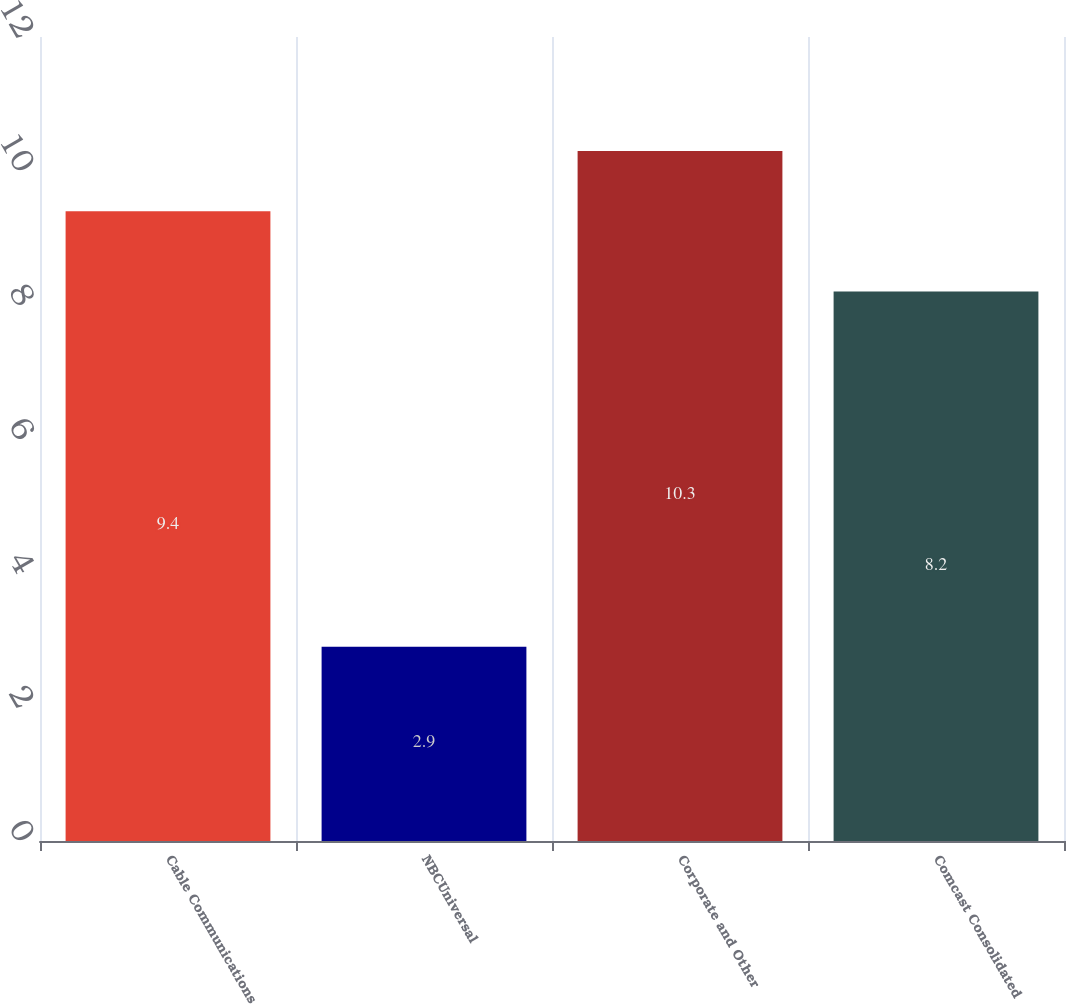Convert chart to OTSL. <chart><loc_0><loc_0><loc_500><loc_500><bar_chart><fcel>Cable Communications<fcel>NBCUniversal<fcel>Corporate and Other<fcel>Comcast Consolidated<nl><fcel>9.4<fcel>2.9<fcel>10.3<fcel>8.2<nl></chart> 